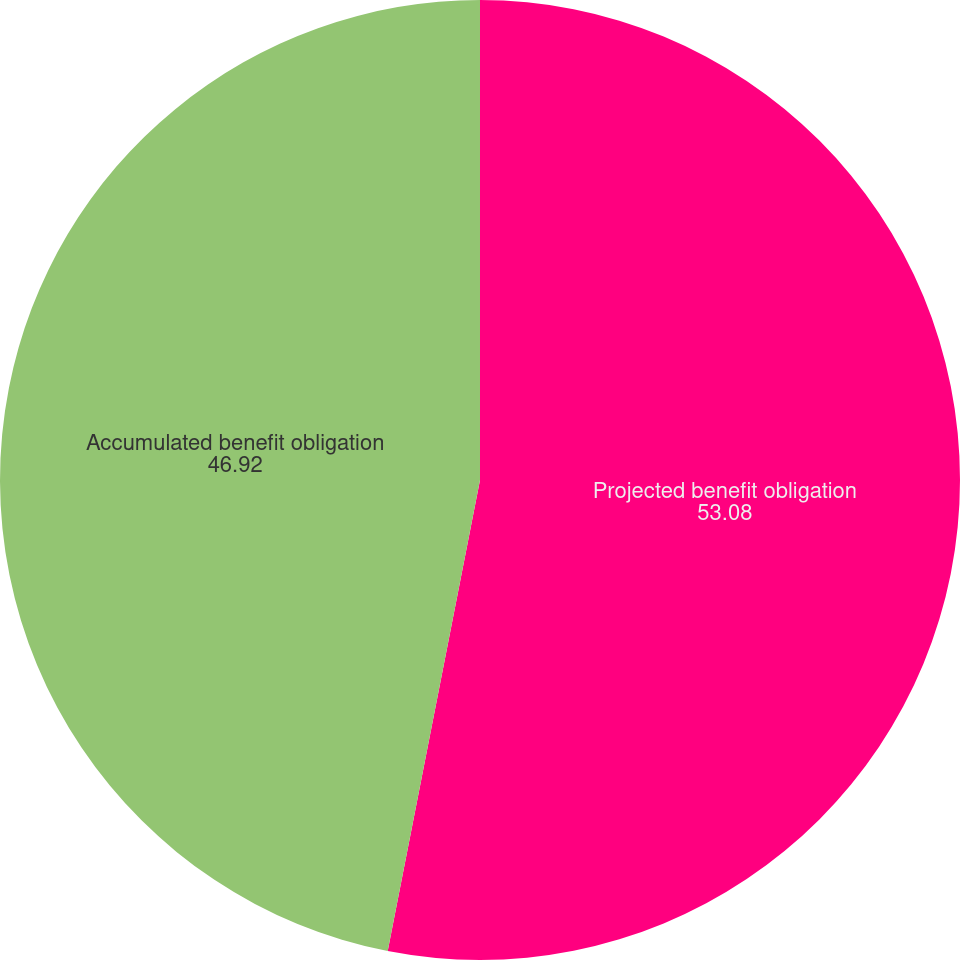Convert chart to OTSL. <chart><loc_0><loc_0><loc_500><loc_500><pie_chart><fcel>Projected benefit obligation<fcel>Accumulated benefit obligation<nl><fcel>53.08%<fcel>46.92%<nl></chart> 